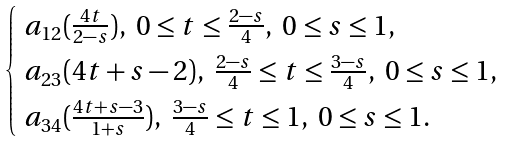Convert formula to latex. <formula><loc_0><loc_0><loc_500><loc_500>\begin{cases} \ a _ { 1 2 } ( \frac { 4 t } { 2 - s } ) , \ 0 \leq t \leq \frac { 2 - s } { 4 } , \ 0 \leq s \leq 1 , \\ \ a _ { 2 3 } ( 4 t + s - 2 ) , \ \frac { 2 - s } { 4 } \leq t \leq \frac { 3 - s } { 4 } , \ 0 \leq s \leq 1 , \\ \ a _ { 3 4 } ( \frac { 4 t + s - 3 } { 1 + s } ) , \ \frac { 3 - s } { 4 } \leq t \leq 1 , \ 0 \leq s \leq 1 . \\ \end{cases}</formula> 